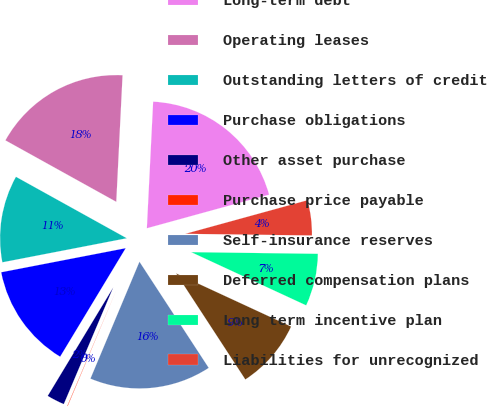Convert chart. <chart><loc_0><loc_0><loc_500><loc_500><pie_chart><fcel>Long-term debt<fcel>Operating leases<fcel>Outstanding letters of credit<fcel>Purchase obligations<fcel>Other asset purchase<fcel>Purchase price payable<fcel>Self-insurance reserves<fcel>Deferred compensation plans<fcel>Long term incentive plan<fcel>Liabilities for unrecognized<nl><fcel>19.94%<fcel>17.73%<fcel>11.1%<fcel>13.31%<fcel>2.27%<fcel>0.06%<fcel>15.52%<fcel>8.9%<fcel>6.69%<fcel>4.48%<nl></chart> 